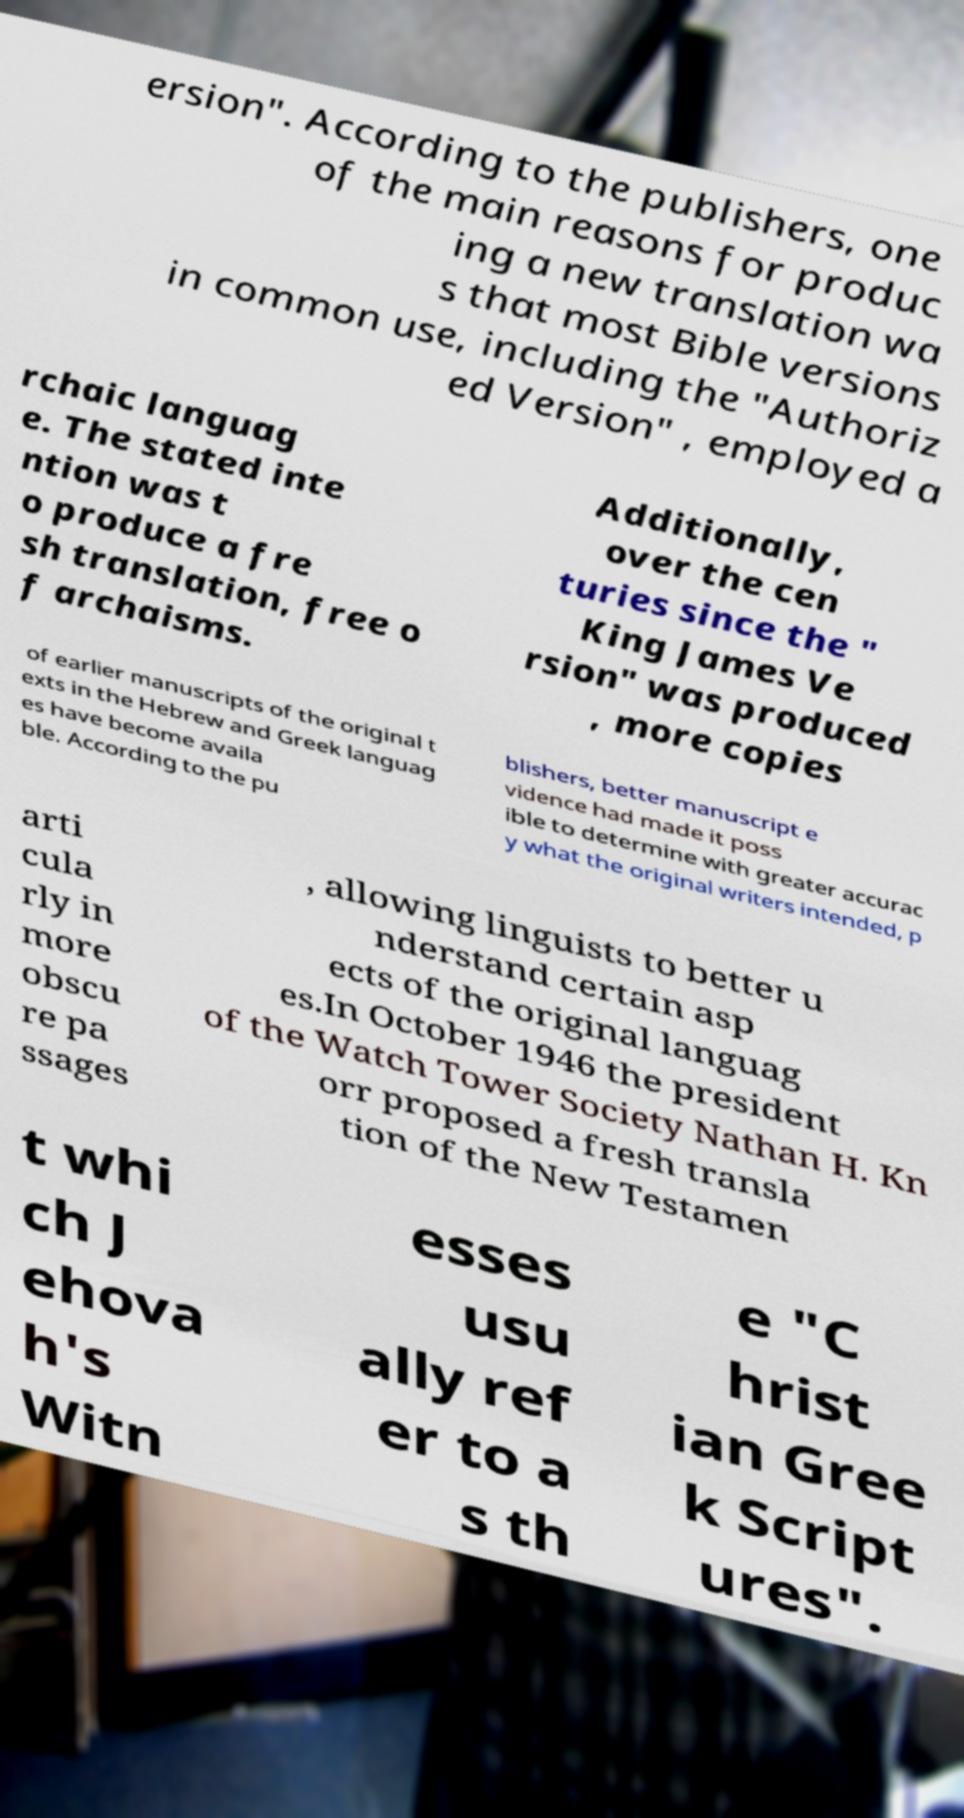Could you assist in decoding the text presented in this image and type it out clearly? ersion". According to the publishers, one of the main reasons for produc ing a new translation wa s that most Bible versions in common use, including the "Authoriz ed Version" , employed a rchaic languag e. The stated inte ntion was t o produce a fre sh translation, free o f archaisms. Additionally, over the cen turies since the " King James Ve rsion" was produced , more copies of earlier manuscripts of the original t exts in the Hebrew and Greek languag es have become availa ble. According to the pu blishers, better manuscript e vidence had made it poss ible to determine with greater accurac y what the original writers intended, p arti cula rly in more obscu re pa ssages , allowing linguists to better u nderstand certain asp ects of the original languag es.In October 1946 the president of the Watch Tower Society Nathan H. Kn orr proposed a fresh transla tion of the New Testamen t whi ch J ehova h's Witn esses usu ally ref er to a s th e "C hrist ian Gree k Script ures". 